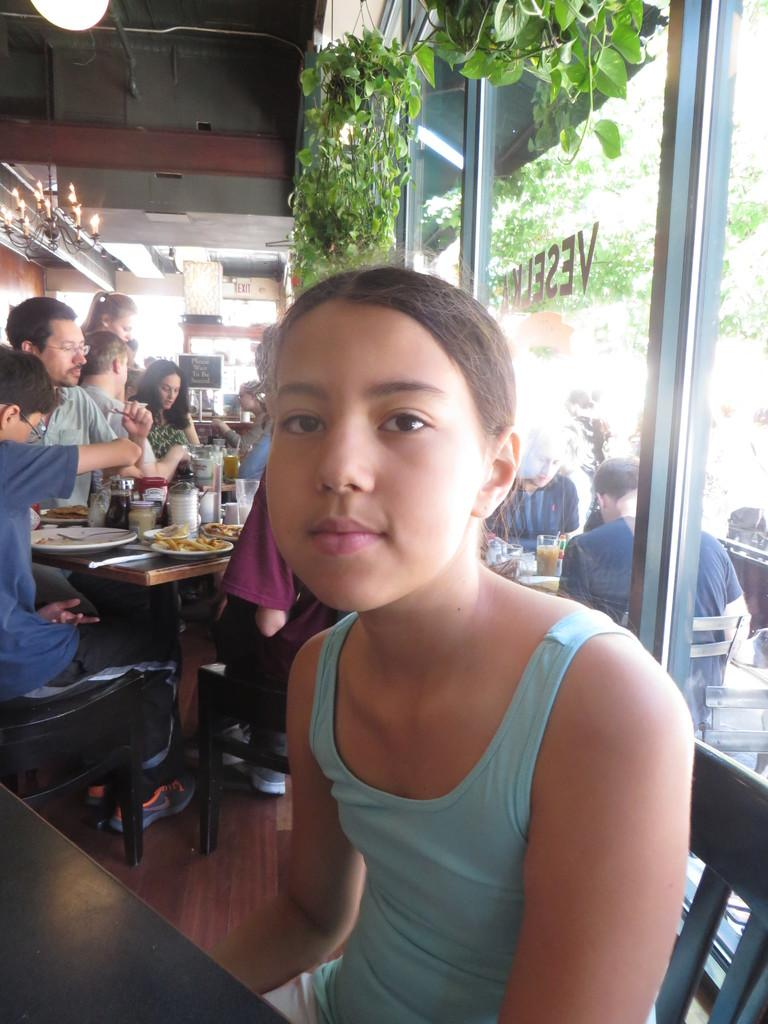How many people are present in the image? There are many people in the image. What are the people doing in the image? The people are sitting on chairs in the image. Where are the chairs located in relation to the table? The chairs are behind a table in the image. What might the people be doing with the items on the table? The people appear to be eating items present on the table. What type of location does the setting resemble? The setting resembles a restaurant. How many dimes are visible on the table in the image? There is no mention of dimes in the image; the focus is on the people, chairs, table, and eating activities. 